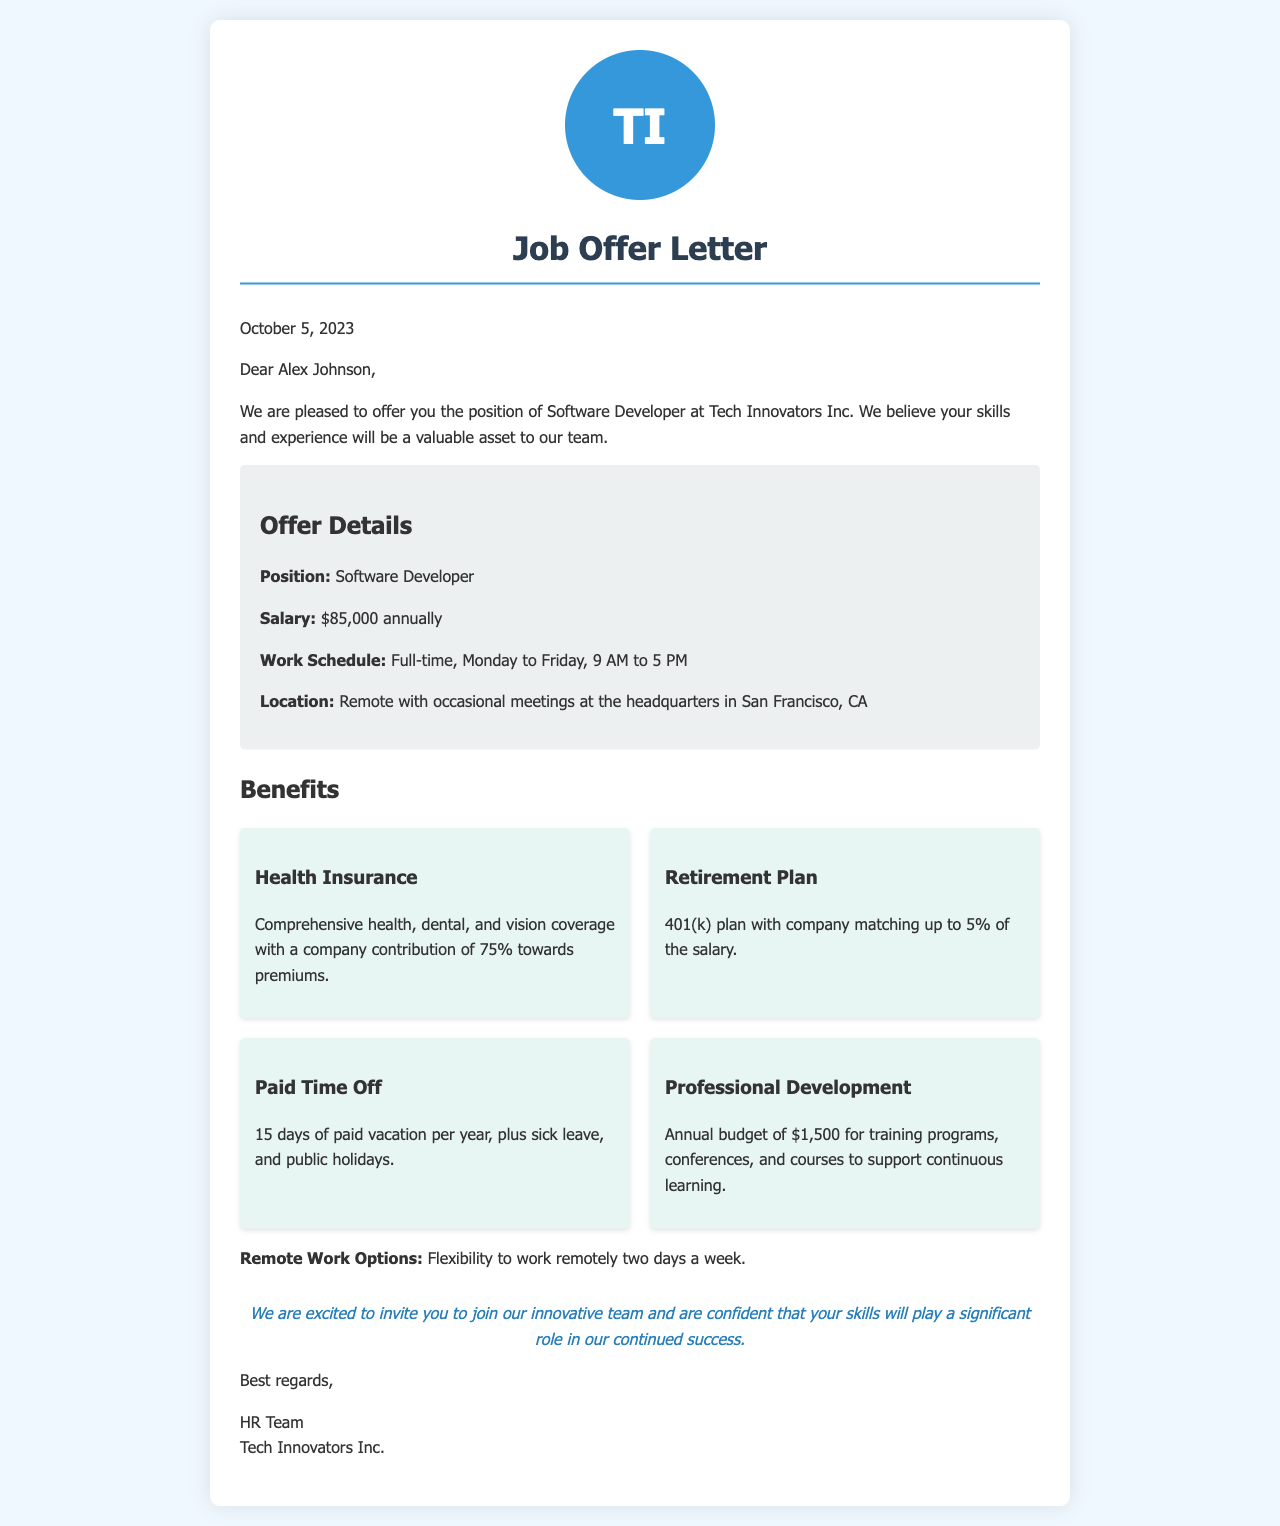What is the position offered? The document states that the position offered is Software Developer.
Answer: Software Developer What is the annual salary? The offer letter specifies the annual salary as $85,000.
Answer: $85,000 How many days of paid vacation are provided? The document mentions that the employee will receive 15 days of paid vacation per year.
Answer: 15 days What is the 401(k) company match percentage? The offer letter states that the company matches up to 5% of the salary for the 401(k) plan.
Answer: 5% What is the budget for professional development? The document specifies an annual budget of $1,500 for training programs, conferences, and courses.
Answer: $1,500 What is the work schedule? The offer letter indicates that the work schedule is full-time, from Monday to Friday, 9 AM to 5 PM.
Answer: Full-time, Monday to Friday, 9 AM to 5 PM How many remote work days are allowed? The document allows for the flexibility to work remotely two days a week.
Answer: Two days Where is the company headquarters located? The offer letter mentions that the headquarters is in San Francisco, CA.
Answer: San Francisco, CA What type of health coverage is included? The document states that the benefits include comprehensive health, dental, and vision coverage.
Answer: Comprehensive health, dental, and vision coverage 